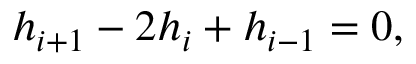Convert formula to latex. <formula><loc_0><loc_0><loc_500><loc_500>{ h _ { i + 1 } } - 2 { h _ { i } } + { h _ { i - 1 } } = 0 ,</formula> 